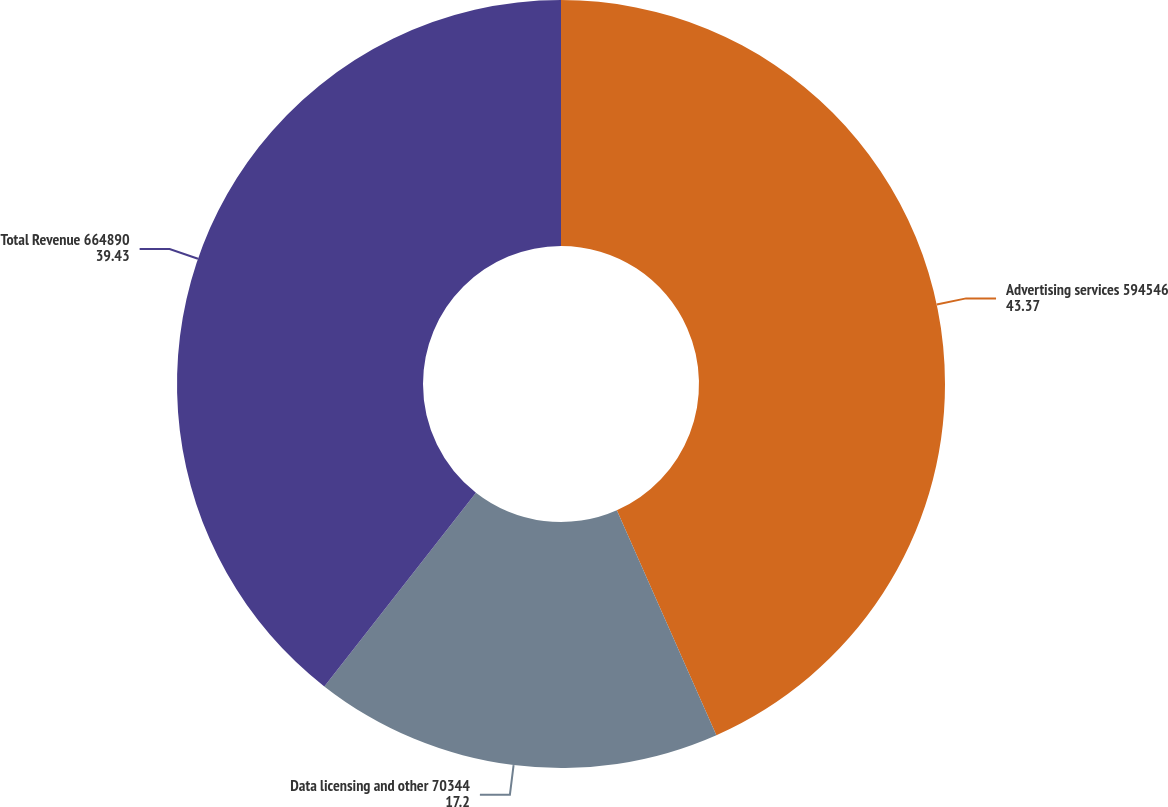Convert chart. <chart><loc_0><loc_0><loc_500><loc_500><pie_chart><fcel>Advertising services 594546<fcel>Data licensing and other 70344<fcel>Total Revenue 664890<nl><fcel>43.37%<fcel>17.2%<fcel>39.43%<nl></chart> 